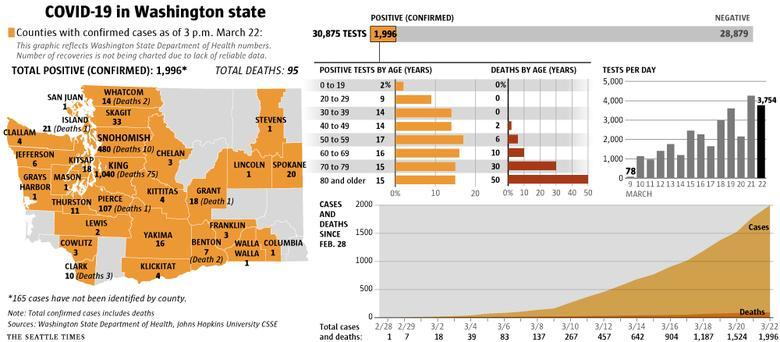How many positive cases are there in Columbia county?
Answer the question with a short phrase. 1 Which age group had the highest death rate? 80 and older What is the number of deaths in Grant county? 1 What was the number of  positive cases in Jefferson county? 6 In how many counties of Washington have deaths been reported? 8 Which two counties reported two deaths each? Benton, Whatcom On which days where the number of tests/day higher than 3000 (in March)? 19, 21, 22 How many counties have reported only one death each? 3 How many positive cases are there in Mason county? 1 Out of the total tests, how many were confirmed positive? 1,996 What is the death rate among those above 80 years of age? 50% What is the number of deaths in Clark county? 3 What is the number of positive cases in King county? 1,040 Which county has the highest number of deaths? King Which age group had the highest number of positive cases? 60 to 69 What is the number of unidentified cases in Washington State? 165 What is the death rate among those below 19 years of age? 0% What is the number of positive cases in in Benton county? 7 How many positive cases are there in Lewis county? 2 What is the number of positive cases in Lincoln County? 1 In which counties is the number of of positive cases higher than 400? King, Snohomish What is the number of positive cases in Spokane county? 20 Out of the total tests, how many were negative? 28,879 